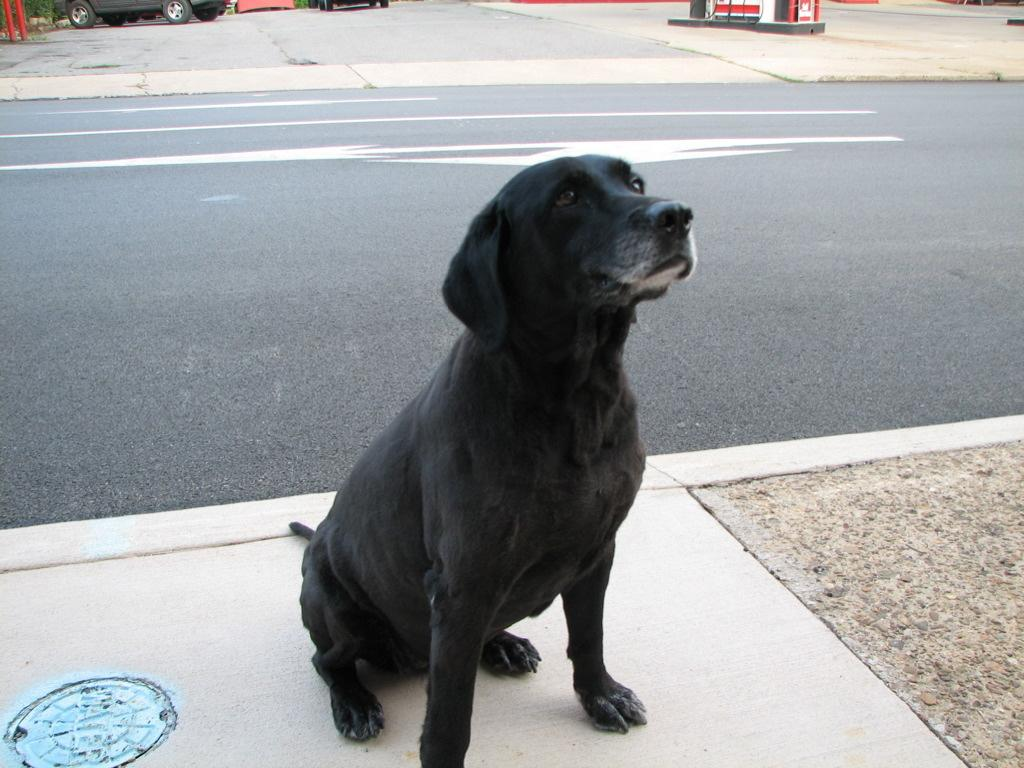What type of animal is in the image? There is a black color dog in the image. Where is the dog located in relation to the road? The dog is sitting near the road. What can be seen in the top left corner of the image? There are cars, a bench, and plants visible in the top left corner of the image. What is located in the top right corner of the image? There is a petrol pump in the top right corner of the image. What type of bear can be seen performing in a cast in the image? There is no bear or performance present in the image; it features a black color dog sitting near the road. 